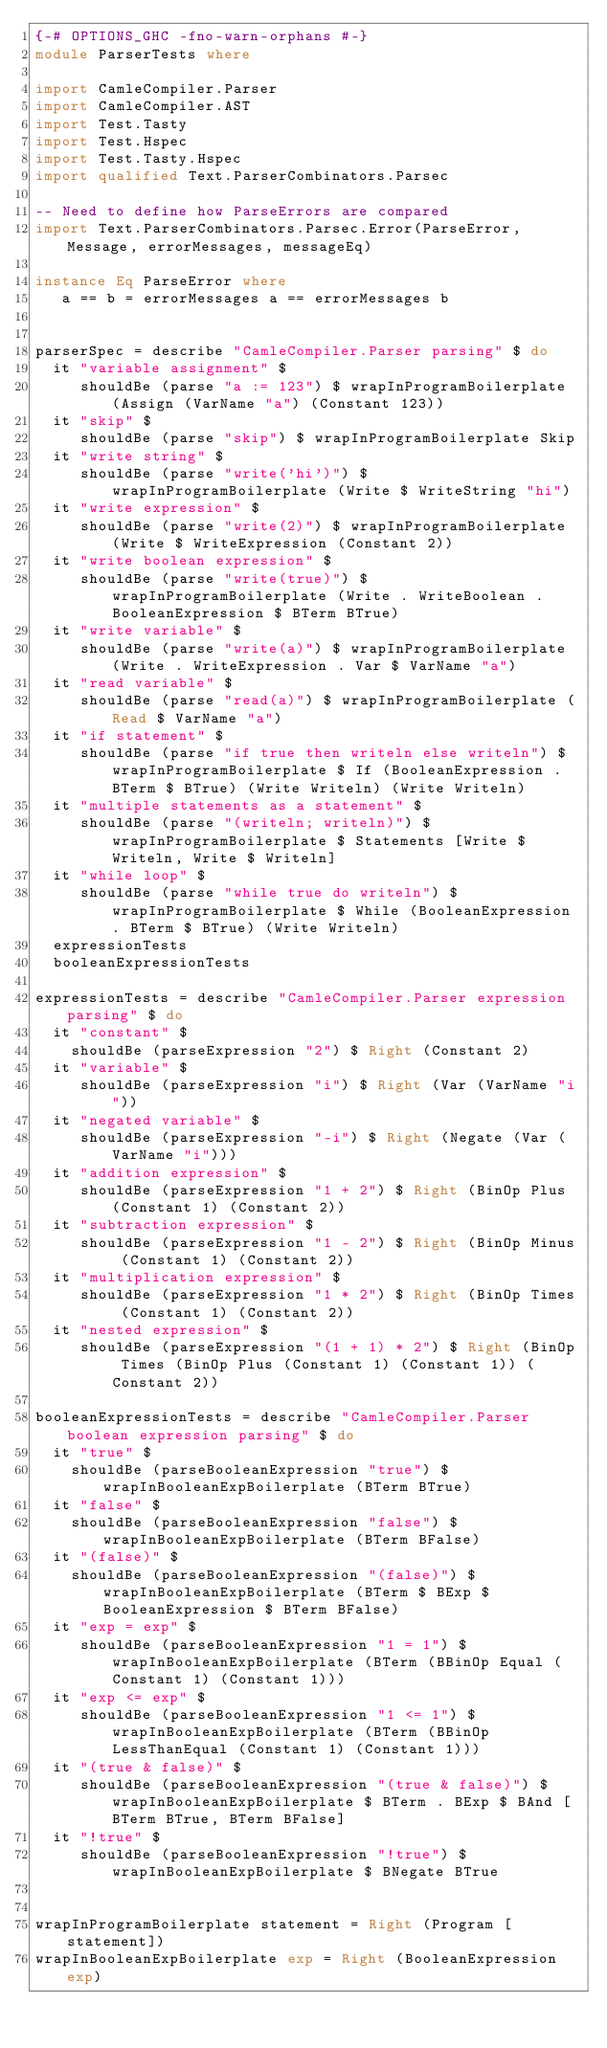<code> <loc_0><loc_0><loc_500><loc_500><_Haskell_>{-# OPTIONS_GHC -fno-warn-orphans #-}
module ParserTests where

import CamleCompiler.Parser
import CamleCompiler.AST
import Test.Tasty
import Test.Hspec
import Test.Tasty.Hspec
import qualified Text.ParserCombinators.Parsec

-- Need to define how ParseErrors are compared
import Text.ParserCombinators.Parsec.Error(ParseError, Message, errorMessages, messageEq)

instance Eq ParseError where
   a == b = errorMessages a == errorMessages b


parserSpec = describe "CamleCompiler.Parser parsing" $ do
  it "variable assignment" $ 
     shouldBe (parse "a := 123") $ wrapInProgramBoilerplate (Assign (VarName "a") (Constant 123))
  it "skip" $ 
     shouldBe (parse "skip") $ wrapInProgramBoilerplate Skip
  it "write string" $ 
     shouldBe (parse "write('hi')") $ wrapInProgramBoilerplate (Write $ WriteString "hi")
  it "write expression" $ 
     shouldBe (parse "write(2)") $ wrapInProgramBoilerplate (Write $ WriteExpression (Constant 2))
  it "write boolean expression" $ 
     shouldBe (parse "write(true)") $ wrapInProgramBoilerplate (Write . WriteBoolean . BooleanExpression $ BTerm BTrue)
  it "write variable" $ 
     shouldBe (parse "write(a)") $ wrapInProgramBoilerplate (Write . WriteExpression . Var $ VarName "a")
  it "read variable" $ 
     shouldBe (parse "read(a)") $ wrapInProgramBoilerplate (Read $ VarName "a")
  it "if statement" $ 
     shouldBe (parse "if true then writeln else writeln") $ wrapInProgramBoilerplate $ If (BooleanExpression . BTerm $ BTrue) (Write Writeln) (Write Writeln)
  it "multiple statements as a statement" $ 
     shouldBe (parse "(writeln; writeln)") $ wrapInProgramBoilerplate $ Statements [Write $ Writeln, Write $ Writeln]
  it "while loop" $ 
     shouldBe (parse "while true do writeln") $ wrapInProgramBoilerplate $ While (BooleanExpression . BTerm $ BTrue) (Write Writeln)
  expressionTests
  booleanExpressionTests

expressionTests = describe "CamleCompiler.Parser expression parsing" $ do
  it "constant" $
    shouldBe (parseExpression "2") $ Right (Constant 2) 
  it "variable" $
     shouldBe (parseExpression "i") $ Right (Var (VarName "i"))
  it "negated variable" $
     shouldBe (parseExpression "-i") $ Right (Negate (Var (VarName "i")))
  it "addition expression" $
     shouldBe (parseExpression "1 + 2") $ Right (BinOp Plus (Constant 1) (Constant 2))
  it "subtraction expression" $
     shouldBe (parseExpression "1 - 2") $ Right (BinOp Minus (Constant 1) (Constant 2))
  it "multiplication expression" $
     shouldBe (parseExpression "1 * 2") $ Right (BinOp Times (Constant 1) (Constant 2))
  it "nested expression" $
     shouldBe (parseExpression "(1 + 1) * 2") $ Right (BinOp Times (BinOp Plus (Constant 1) (Constant 1)) (Constant 2))

booleanExpressionTests = describe "CamleCompiler.Parser boolean expression parsing" $ do
  it "true" $
    shouldBe (parseBooleanExpression "true") $ wrapInBooleanExpBoilerplate (BTerm BTrue) 
  it "false" $
    shouldBe (parseBooleanExpression "false") $ wrapInBooleanExpBoilerplate (BTerm BFalse) 
  it "(false)" $
    shouldBe (parseBooleanExpression "(false)") $ wrapInBooleanExpBoilerplate (BTerm $ BExp $ BooleanExpression $ BTerm BFalse) 
  it "exp = exp" $
     shouldBe (parseBooleanExpression "1 = 1") $ wrapInBooleanExpBoilerplate (BTerm (BBinOp Equal (Constant 1) (Constant 1)))
  it "exp <= exp" $
     shouldBe (parseBooleanExpression "1 <= 1") $ wrapInBooleanExpBoilerplate (BTerm (BBinOp LessThanEqual (Constant 1) (Constant 1)))
  it "(true & false)" $
     shouldBe (parseBooleanExpression "(true & false)") $ wrapInBooleanExpBoilerplate $ BTerm . BExp $ BAnd [BTerm BTrue, BTerm BFalse]
  it "!true" $
     shouldBe (parseBooleanExpression "!true") $ wrapInBooleanExpBoilerplate $ BNegate BTrue


wrapInProgramBoilerplate statement = Right (Program [statement])
wrapInBooleanExpBoilerplate exp = Right (BooleanExpression exp)
</code> 